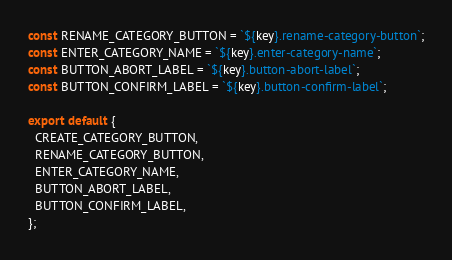<code> <loc_0><loc_0><loc_500><loc_500><_JavaScript_>const RENAME_CATEGORY_BUTTON = `${key}.rename-category-button`;
const ENTER_CATEGORY_NAME = `${key}.enter-category-name`;
const BUTTON_ABORT_LABEL = `${key}.button-abort-label`;
const BUTTON_CONFIRM_LABEL = `${key}.button-confirm-label`;

export default {
  CREATE_CATEGORY_BUTTON,
  RENAME_CATEGORY_BUTTON,
  ENTER_CATEGORY_NAME,
  BUTTON_ABORT_LABEL,
  BUTTON_CONFIRM_LABEL,
};
</code> 